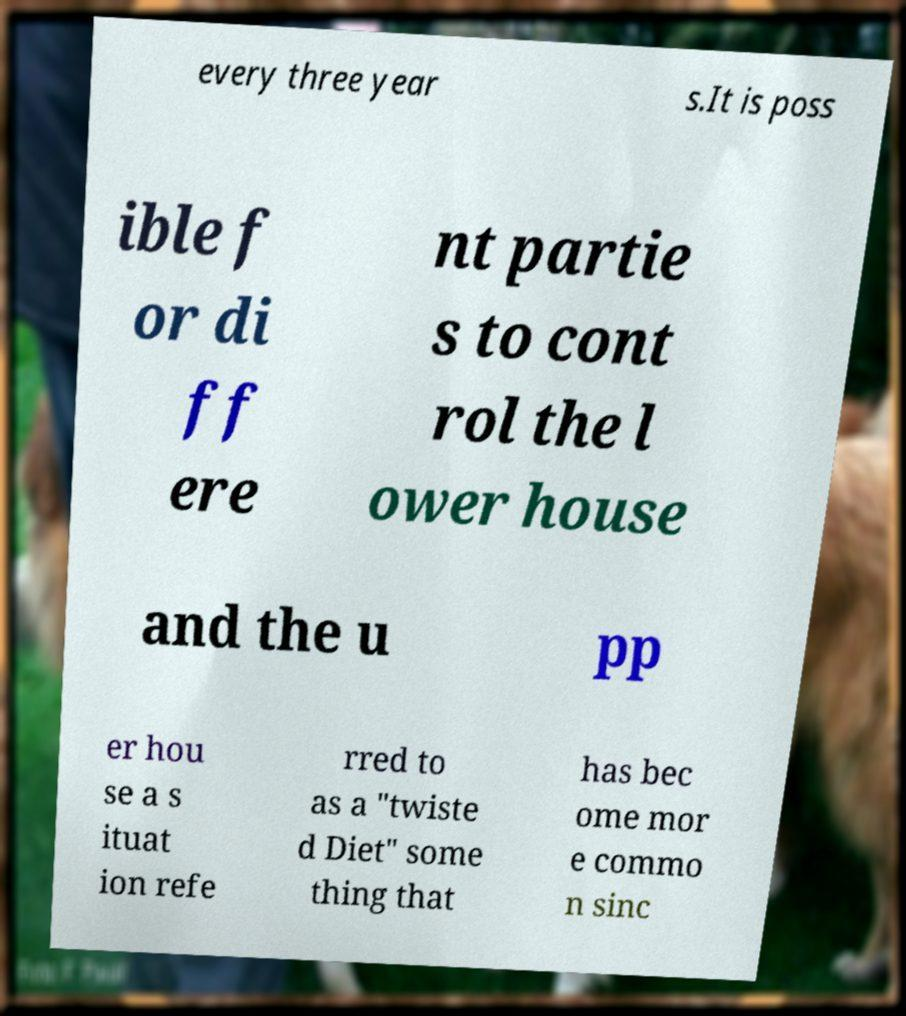Can you accurately transcribe the text from the provided image for me? every three year s.It is poss ible f or di ff ere nt partie s to cont rol the l ower house and the u pp er hou se a s ituat ion refe rred to as a "twiste d Diet" some thing that has bec ome mor e commo n sinc 